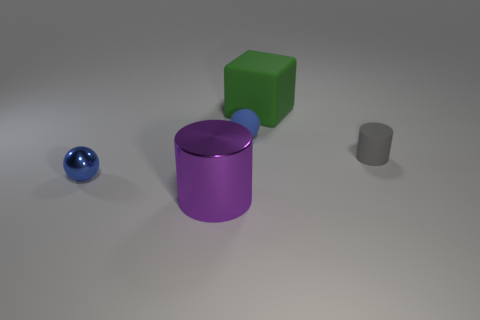Are the shadows consistent with a single light source? Yes, the shadows cast by the blocks and the cylinder suggest there is a single light source coming from the top left, given their direction and length. 